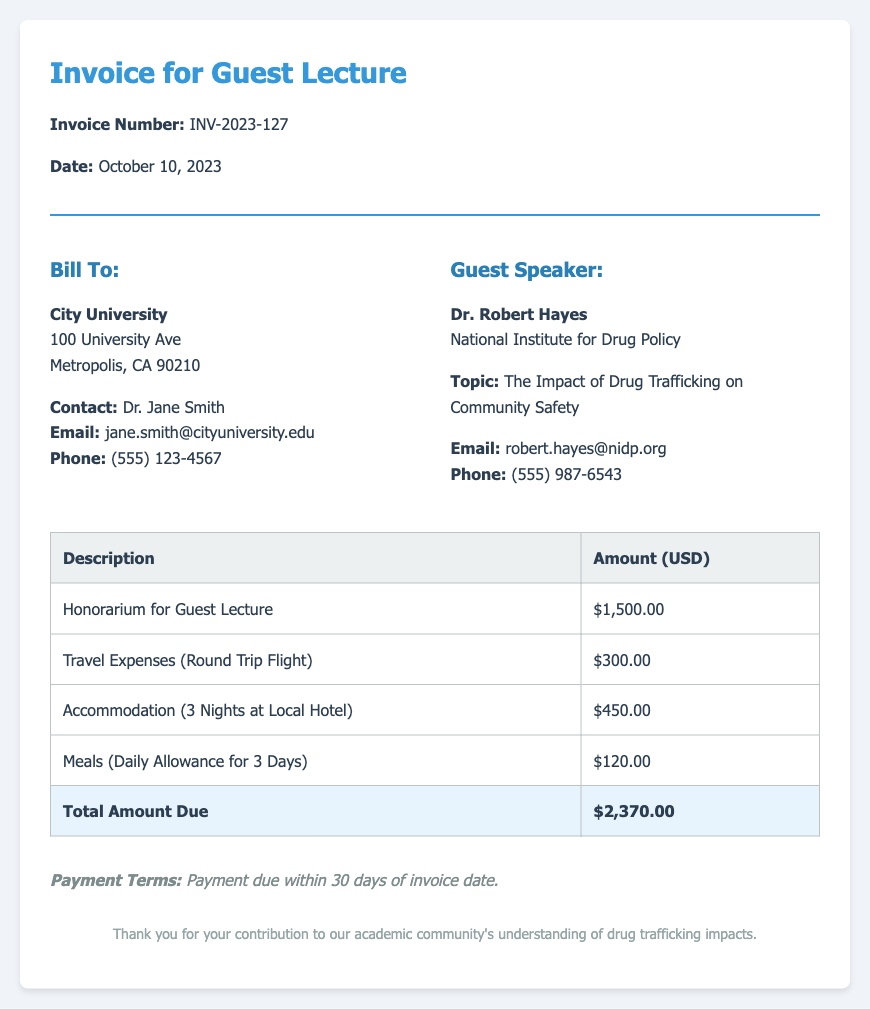What is the invoice number? The invoice number is listed at the top of the document, indicating a unique identifier for this transaction.
Answer: INV-2023-127 Who is the guest speaker? The document specifies the name of the guest speaker providing the lecture, which is stated clearly in the invoice details.
Answer: Dr. Robert Hayes What is the date of the invoice? The date of the invoice is mentioned right after the invoice number, providing a reference for when the invoice was issued.
Answer: October 10, 2023 What is the total amount due? The document contains a summary section that specifies the total amount owed for the services rendered.
Answer: $2,370.00 How much is the honorarium for the guest lecture? The honorarium amount is specified in the itemized fees table of the document, clearly indicating the fee for the guest speaker's lecture.
Answer: $1,500.00 What are the payment terms? The payment terms section at the bottom of the document outlines the timeframe for payment following the invoice date.
Answer: Payment due within 30 days of invoice date What type of expenses are included in the fees? An examination of the fees table reveals various types of expenses incurred for the guest speaker's visit.
Answer: Travel, accommodation, meals, honorarium How many nights of accommodation are billed? The accommodation expense specifies the duration of the speaker's stay, providing a clear count of nights billed.
Answer: 3 Nights Which university is billed for this lecture? The invoice clearly lists the name of the institution being billed for the guest lecture services.
Answer: City University 